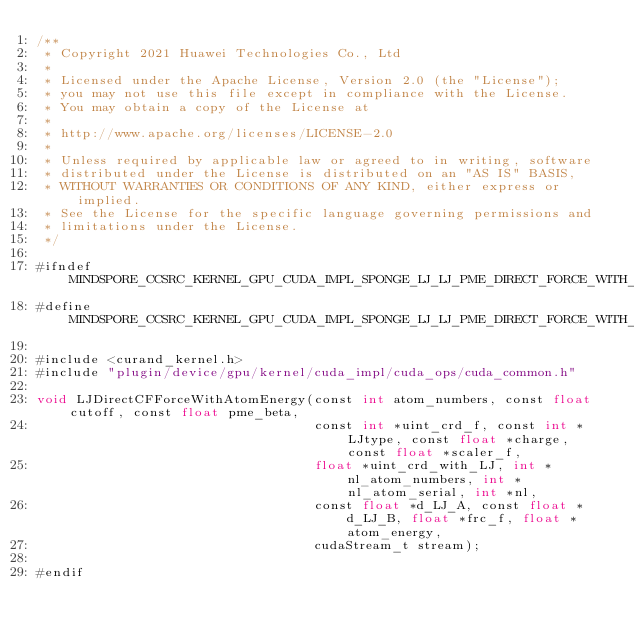<code> <loc_0><loc_0><loc_500><loc_500><_Cuda_>/**
 * Copyright 2021 Huawei Technologies Co., Ltd
 *
 * Licensed under the Apache License, Version 2.0 (the "License");
 * you may not use this file except in compliance with the License.
 * You may obtain a copy of the License at
 *
 * http://www.apache.org/licenses/LICENSE-2.0
 *
 * Unless required by applicable law or agreed to in writing, software
 * distributed under the License is distributed on an "AS IS" BASIS,
 * WITHOUT WARRANTIES OR CONDITIONS OF ANY KIND, either express or implied.
 * See the License for the specific language governing permissions and
 * limitations under the License.
 */

#ifndef MINDSPORE_CCSRC_KERNEL_GPU_CUDA_IMPL_SPONGE_LJ_LJ_PME_DIRECT_FORCE_WITH_ATOM_ENERGY_IMPL_H_
#define MINDSPORE_CCSRC_KERNEL_GPU_CUDA_IMPL_SPONGE_LJ_LJ_PME_DIRECT_FORCE_WITH_ATOM_ENERGY_IMPL_H_

#include <curand_kernel.h>
#include "plugin/device/gpu/kernel/cuda_impl/cuda_ops/cuda_common.h"

void LJDirectCFForceWithAtomEnergy(const int atom_numbers, const float cutoff, const float pme_beta,
                                   const int *uint_crd_f, const int *LJtype, const float *charge, const float *scaler_f,
                                   float *uint_crd_with_LJ, int *nl_atom_numbers, int *nl_atom_serial, int *nl,
                                   const float *d_LJ_A, const float *d_LJ_B, float *frc_f, float *atom_energy,
                                   cudaStream_t stream);

#endif
</code> 